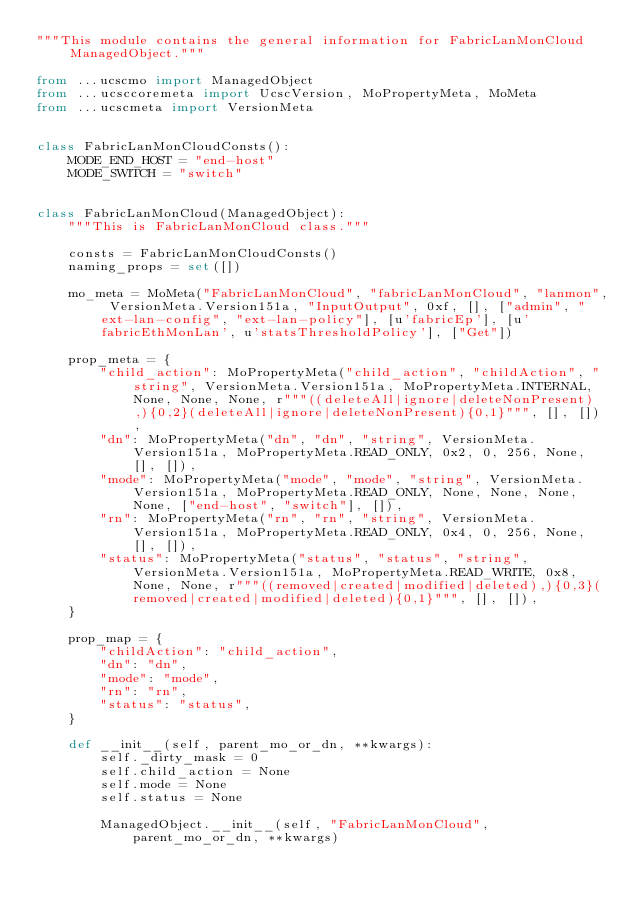<code> <loc_0><loc_0><loc_500><loc_500><_Python_>"""This module contains the general information for FabricLanMonCloud ManagedObject."""

from ...ucscmo import ManagedObject
from ...ucsccoremeta import UcscVersion, MoPropertyMeta, MoMeta
from ...ucscmeta import VersionMeta


class FabricLanMonCloudConsts():
    MODE_END_HOST = "end-host"
    MODE_SWITCH = "switch"


class FabricLanMonCloud(ManagedObject):
    """This is FabricLanMonCloud class."""

    consts = FabricLanMonCloudConsts()
    naming_props = set([])

    mo_meta = MoMeta("FabricLanMonCloud", "fabricLanMonCloud", "lanmon", VersionMeta.Version151a, "InputOutput", 0xf, [], ["admin", "ext-lan-config", "ext-lan-policy"], [u'fabricEp'], [u'fabricEthMonLan', u'statsThresholdPolicy'], ["Get"])

    prop_meta = {
        "child_action": MoPropertyMeta("child_action", "childAction", "string", VersionMeta.Version151a, MoPropertyMeta.INTERNAL, None, None, None, r"""((deleteAll|ignore|deleteNonPresent),){0,2}(deleteAll|ignore|deleteNonPresent){0,1}""", [], []), 
        "dn": MoPropertyMeta("dn", "dn", "string", VersionMeta.Version151a, MoPropertyMeta.READ_ONLY, 0x2, 0, 256, None, [], []), 
        "mode": MoPropertyMeta("mode", "mode", "string", VersionMeta.Version151a, MoPropertyMeta.READ_ONLY, None, None, None, None, ["end-host", "switch"], []), 
        "rn": MoPropertyMeta("rn", "rn", "string", VersionMeta.Version151a, MoPropertyMeta.READ_ONLY, 0x4, 0, 256, None, [], []), 
        "status": MoPropertyMeta("status", "status", "string", VersionMeta.Version151a, MoPropertyMeta.READ_WRITE, 0x8, None, None, r"""((removed|created|modified|deleted),){0,3}(removed|created|modified|deleted){0,1}""", [], []), 
    }

    prop_map = {
        "childAction": "child_action", 
        "dn": "dn", 
        "mode": "mode", 
        "rn": "rn", 
        "status": "status", 
    }

    def __init__(self, parent_mo_or_dn, **kwargs):
        self._dirty_mask = 0
        self.child_action = None
        self.mode = None
        self.status = None

        ManagedObject.__init__(self, "FabricLanMonCloud", parent_mo_or_dn, **kwargs)

</code> 